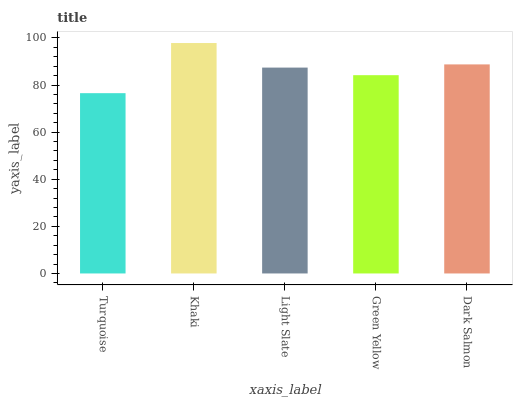Is Turquoise the minimum?
Answer yes or no. Yes. Is Khaki the maximum?
Answer yes or no. Yes. Is Light Slate the minimum?
Answer yes or no. No. Is Light Slate the maximum?
Answer yes or no. No. Is Khaki greater than Light Slate?
Answer yes or no. Yes. Is Light Slate less than Khaki?
Answer yes or no. Yes. Is Light Slate greater than Khaki?
Answer yes or no. No. Is Khaki less than Light Slate?
Answer yes or no. No. Is Light Slate the high median?
Answer yes or no. Yes. Is Light Slate the low median?
Answer yes or no. Yes. Is Green Yellow the high median?
Answer yes or no. No. Is Turquoise the low median?
Answer yes or no. No. 